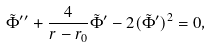<formula> <loc_0><loc_0><loc_500><loc_500>\tilde { \Phi } ^ { \prime \prime } + \frac { 4 } { r - r _ { 0 } } \tilde { \Phi } ^ { \prime } - 2 ( \tilde { \Phi } ^ { \prime } ) ^ { 2 } = 0 ,</formula> 